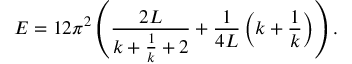Convert formula to latex. <formula><loc_0><loc_0><loc_500><loc_500>E = 1 2 \pi ^ { 2 } \left ( \frac { 2 L } { k + \frac { 1 } { k } + 2 } + \frac { 1 } { 4 L } \left ( k + \frac { 1 } { k } \right ) \right ) .</formula> 